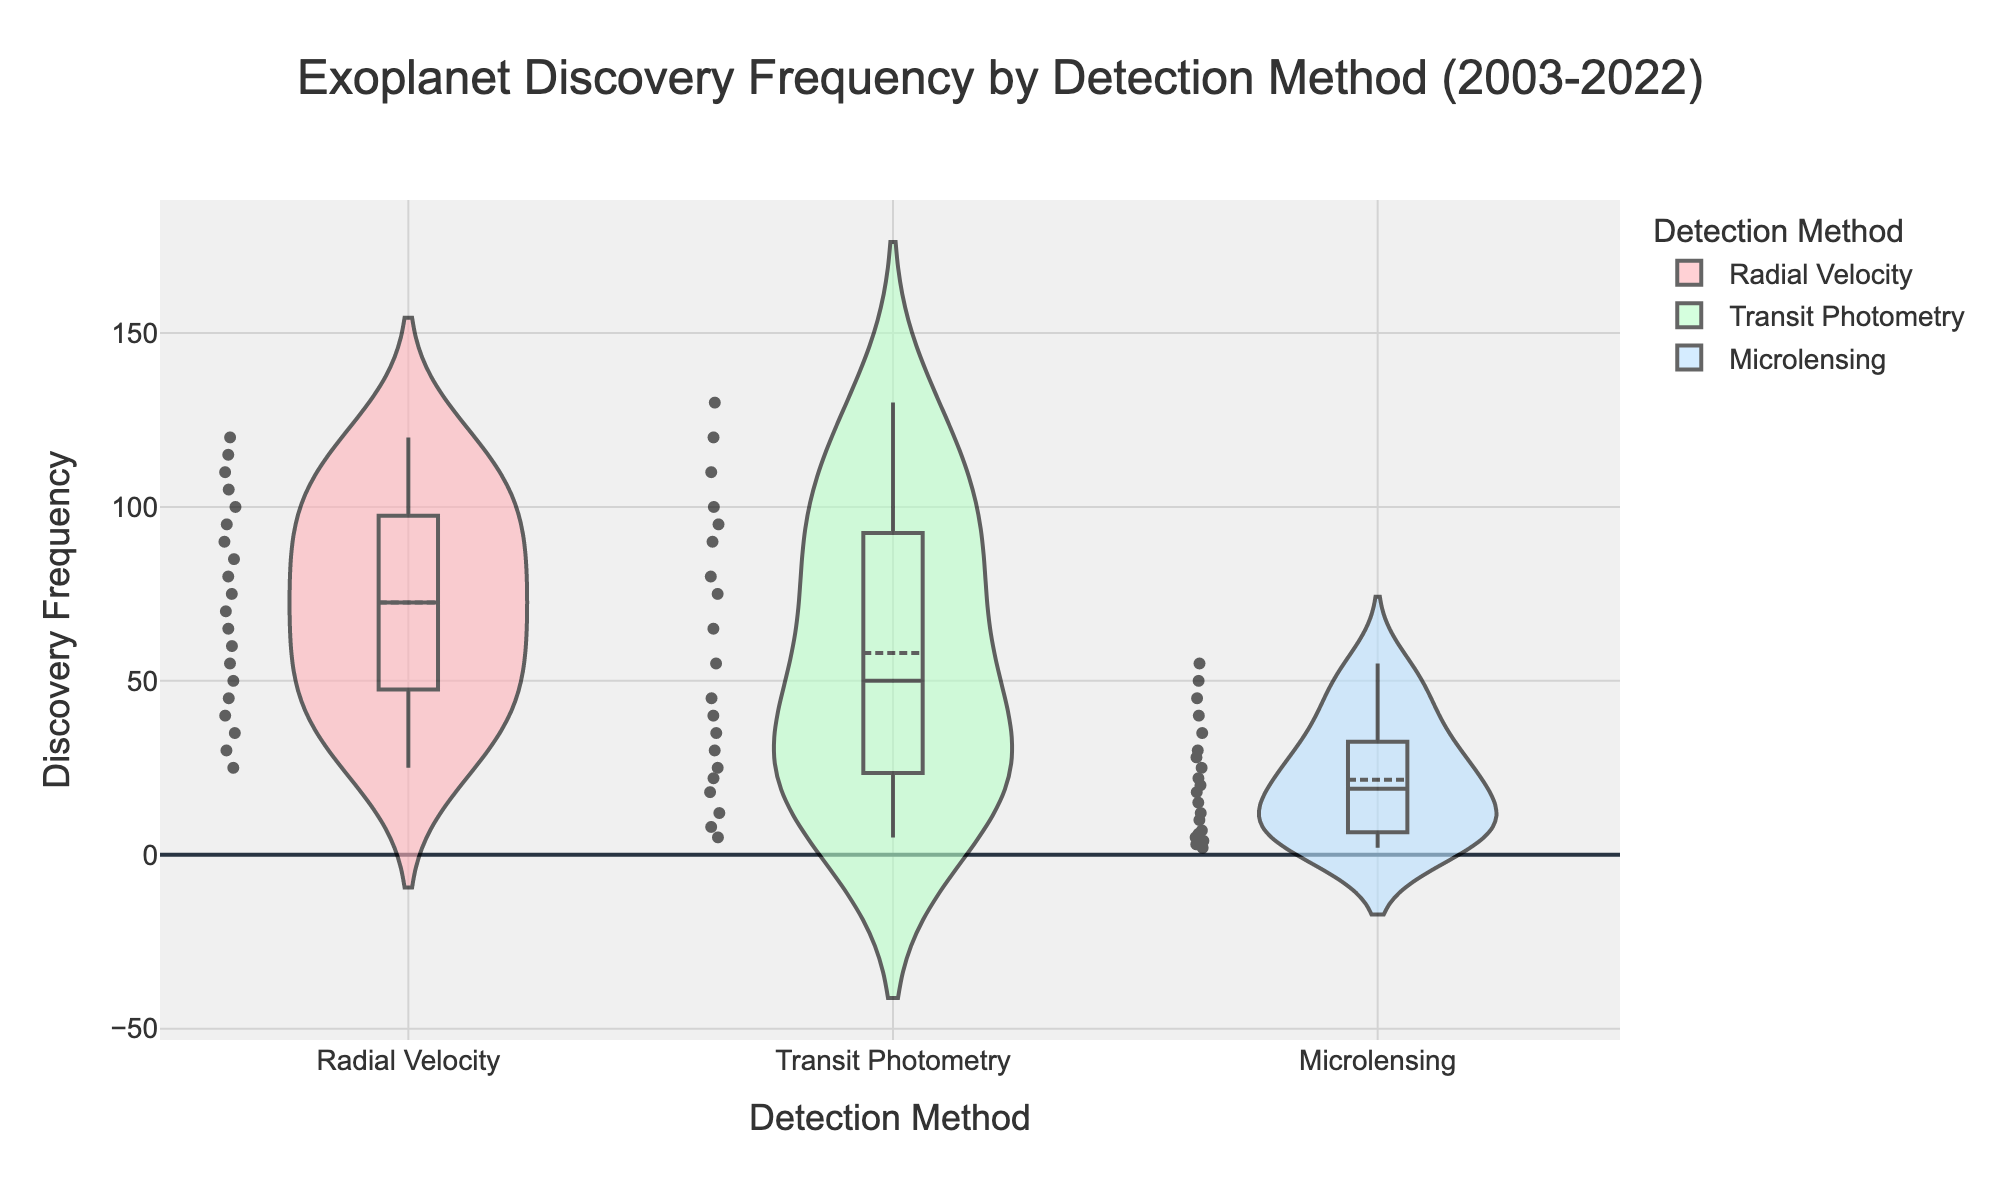What is the title of the figure? The title of the figure is located at the top center of the plot.
Answer: Exoplanet Discovery Frequency by Detection Method (2003-2022) What is the y-axis title? The y-axis title is written vertically along the y-axis.
Answer: Discovery Frequency What detection method shows the highest number of exoplanet discoveries in any year? By observing the peaks of the violin plots, Radial Velocity shows the highest discovery frequency.
Answer: Radial Velocity Which detection method has the widest range of discovery frequencies? The width of the violin chart indicates the spread of the data. Transit Photometry has the widest range, as its violin shape is the widest.
Answer: Transit Photometry What's the average frequency of exoplanet discoveries for the Radial Velocity method? The average can be estimated by looking at the mean line within the violin plot filled for Radial Velocity.
Answer: Approximately 72.5 How does the median discovery frequency of Microlensing compare to Radial Velocity? The box plots within the violins show the medians. Microlensing has a lower median frequency compared to Radial Velocity.
Answer: Microlensing is lower Which detection method has the smallest interquartile range (IQR)? Look at the height of the boxes within the violins. Radial Velocity has the smallest IQR since its box is the shortest.
Answer: Radial Velocity Is the number of discoveries using Transit Photometry method higher in 2022 compared to 2010? The position of the 2022 and 2010 data points within the violin plot for Transit Photometry shows that 2022 has a higher value.
Answer: Yes Does the box plot overlay for any detection method show outliers? The points outside the whiskers in the box plots represent outliers. None of the detection methods show points outside the whiskers.
Answer: No What's the midpoint value of the frequency range for Transit Photometry? The midpoint can be estimated by averaging the minimum and maximum frequency values of the violin plot. The minimum is around 5, and the maximum is around 130. So, (5+130)/2 = 67.5
Answer: 67.5 